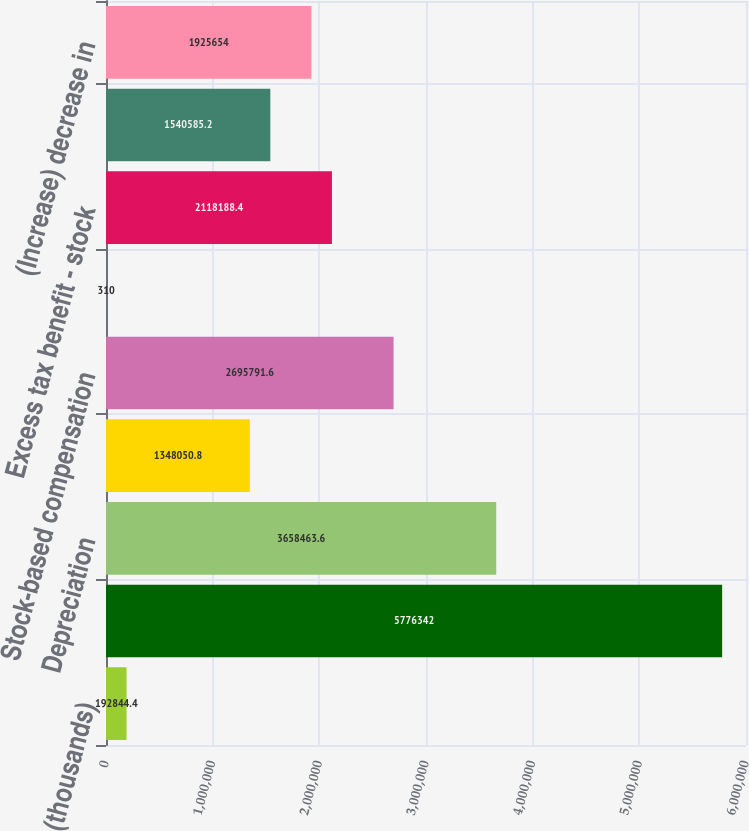Convert chart. <chart><loc_0><loc_0><loc_500><loc_500><bar_chart><fcel>(thousands)<fcel>Net income<fcel>Depreciation<fcel>Amortization of intangibles<fcel>Stock-based compensation<fcel>Other non-cash activity<fcel>Excess tax benefit - stock<fcel>Deferred income taxes<fcel>(Increase) decrease in<nl><fcel>192844<fcel>5.77634e+06<fcel>3.65846e+06<fcel>1.34805e+06<fcel>2.69579e+06<fcel>310<fcel>2.11819e+06<fcel>1.54059e+06<fcel>1.92565e+06<nl></chart> 